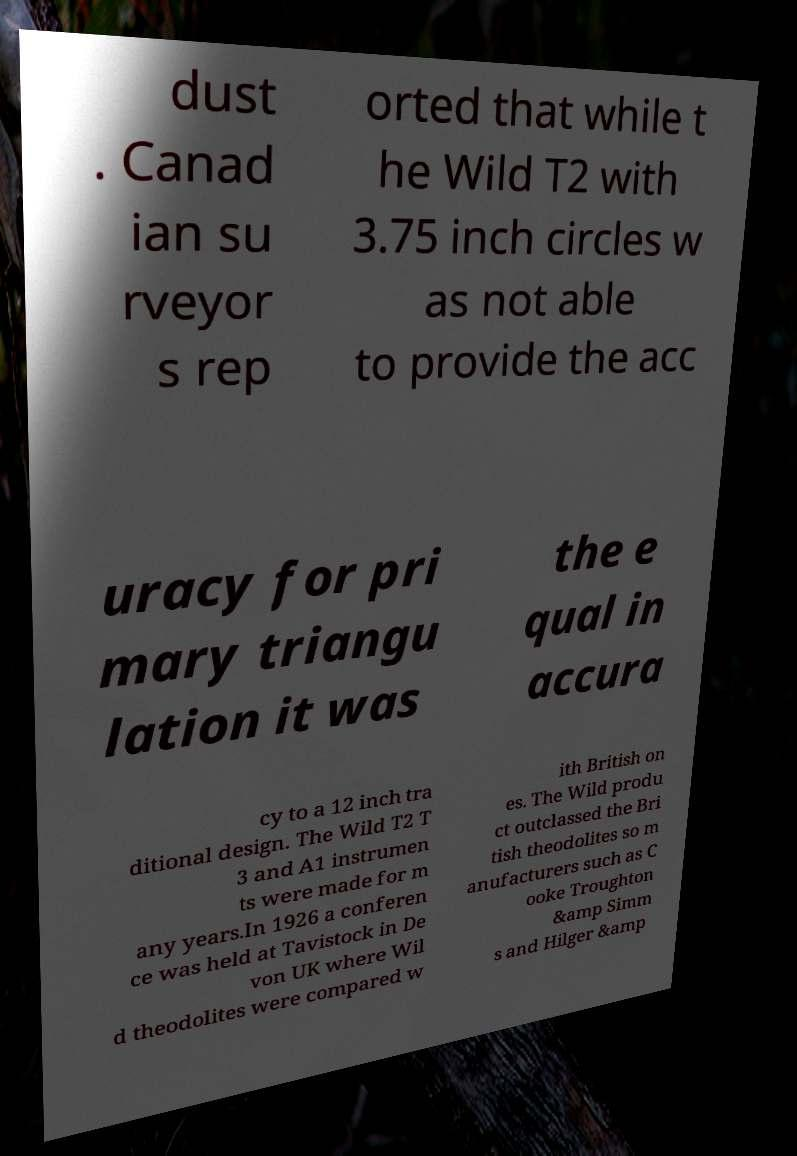For documentation purposes, I need the text within this image transcribed. Could you provide that? dust . Canad ian su rveyor s rep orted that while t he Wild T2 with 3.75 inch circles w as not able to provide the acc uracy for pri mary triangu lation it was the e qual in accura cy to a 12 inch tra ditional design. The Wild T2 T 3 and A1 instrumen ts were made for m any years.In 1926 a conferen ce was held at Tavistock in De von UK where Wil d theodolites were compared w ith British on es. The Wild produ ct outclassed the Bri tish theodolites so m anufacturers such as C ooke Troughton &amp Simm s and Hilger &amp 